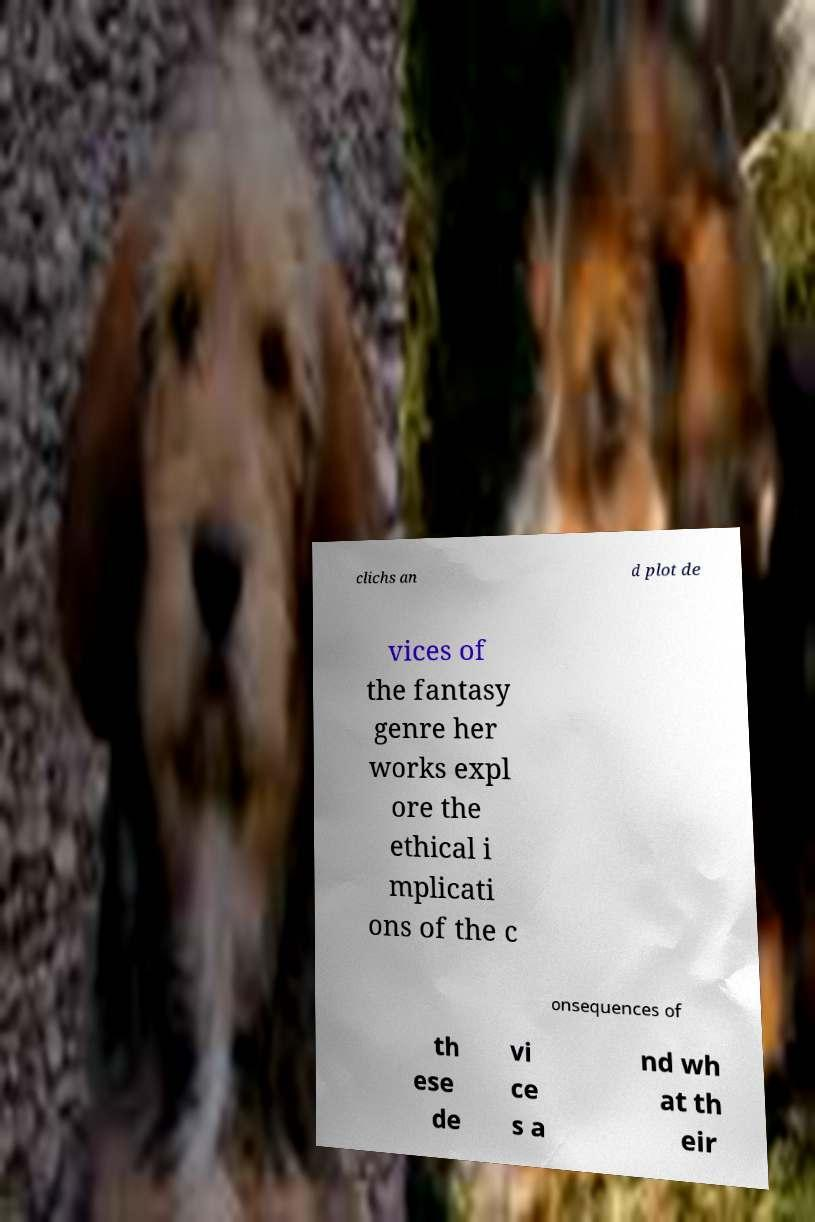Please identify and transcribe the text found in this image. clichs an d plot de vices of the fantasy genre her works expl ore the ethical i mplicati ons of the c onsequences of th ese de vi ce s a nd wh at th eir 